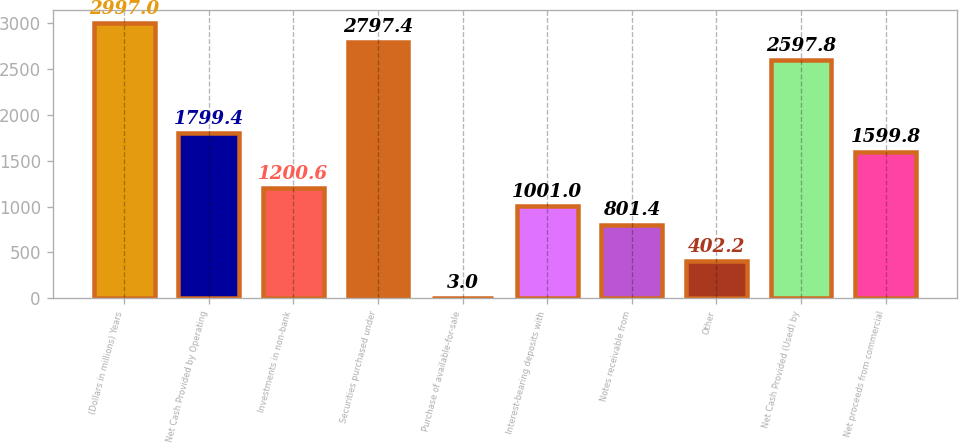<chart> <loc_0><loc_0><loc_500><loc_500><bar_chart><fcel>(Dollars in millions) Years<fcel>Net Cash Provided by Operating<fcel>Investments in non-bank<fcel>Securities purchased under<fcel>Purchase of available-for-sale<fcel>Interest-bearing deposits with<fcel>Notes receivable from<fcel>Other<fcel>Net Cash Provided (Used) by<fcel>Net proceeds from commercial<nl><fcel>2997<fcel>1799.4<fcel>1200.6<fcel>2797.4<fcel>3<fcel>1001<fcel>801.4<fcel>402.2<fcel>2597.8<fcel>1599.8<nl></chart> 